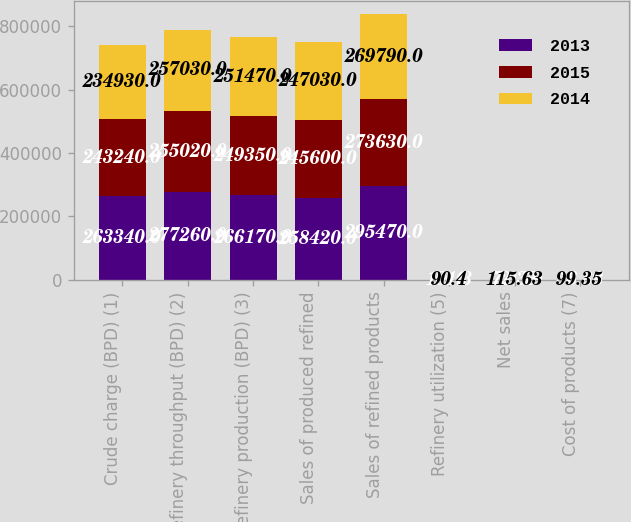Convert chart. <chart><loc_0><loc_0><loc_500><loc_500><stacked_bar_chart><ecel><fcel>Crude charge (BPD) (1)<fcel>Refinery throughput (BPD) (2)<fcel>Refinery production (BPD) (3)<fcel>Sales of produced refined<fcel>Sales of refined products<fcel>Refinery utilization (5)<fcel>Net sales<fcel>Cost of products (7)<nl><fcel>2013<fcel>263340<fcel>277260<fcel>266170<fcel>258420<fcel>295470<fcel>101.3<fcel>72.33<fcel>56.88<nl><fcel>2015<fcel>243240<fcel>255020<fcel>249350<fcel>245600<fcel>273630<fcel>93.6<fcel>110.79<fcel>98.39<nl><fcel>2014<fcel>234930<fcel>257030<fcel>251470<fcel>247030<fcel>269790<fcel>90.4<fcel>115.63<fcel>99.35<nl></chart> 